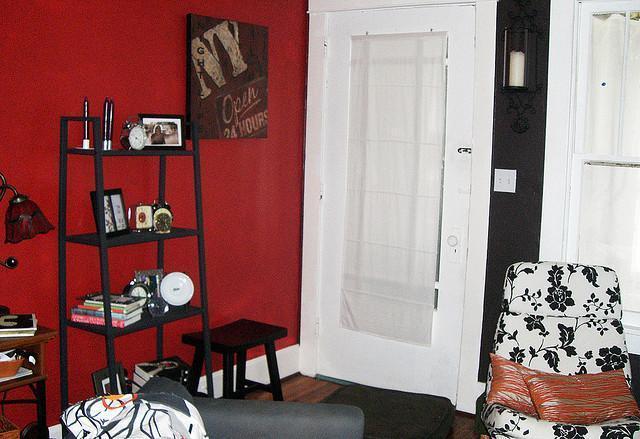How many donuts are there?
Give a very brief answer. 0. 